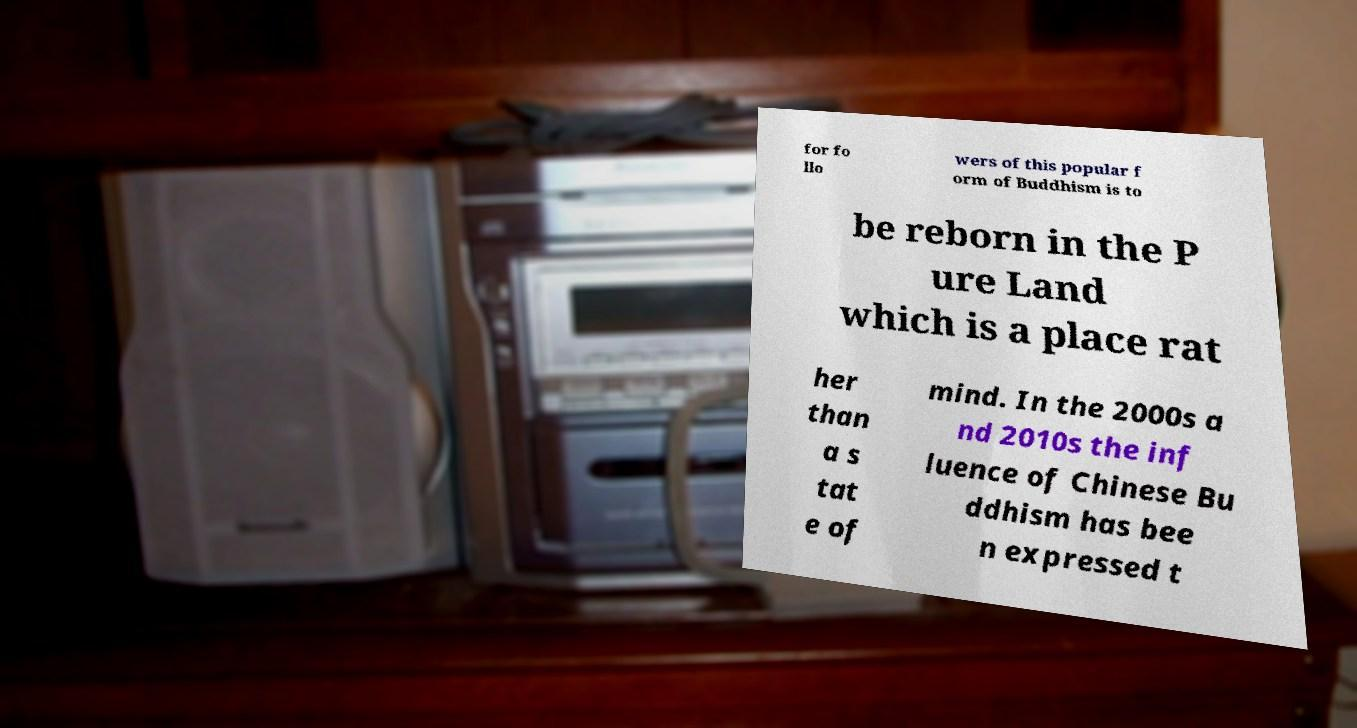For documentation purposes, I need the text within this image transcribed. Could you provide that? for fo llo wers of this popular f orm of Buddhism is to be reborn in the P ure Land which is a place rat her than a s tat e of mind. In the 2000s a nd 2010s the inf luence of Chinese Bu ddhism has bee n expressed t 